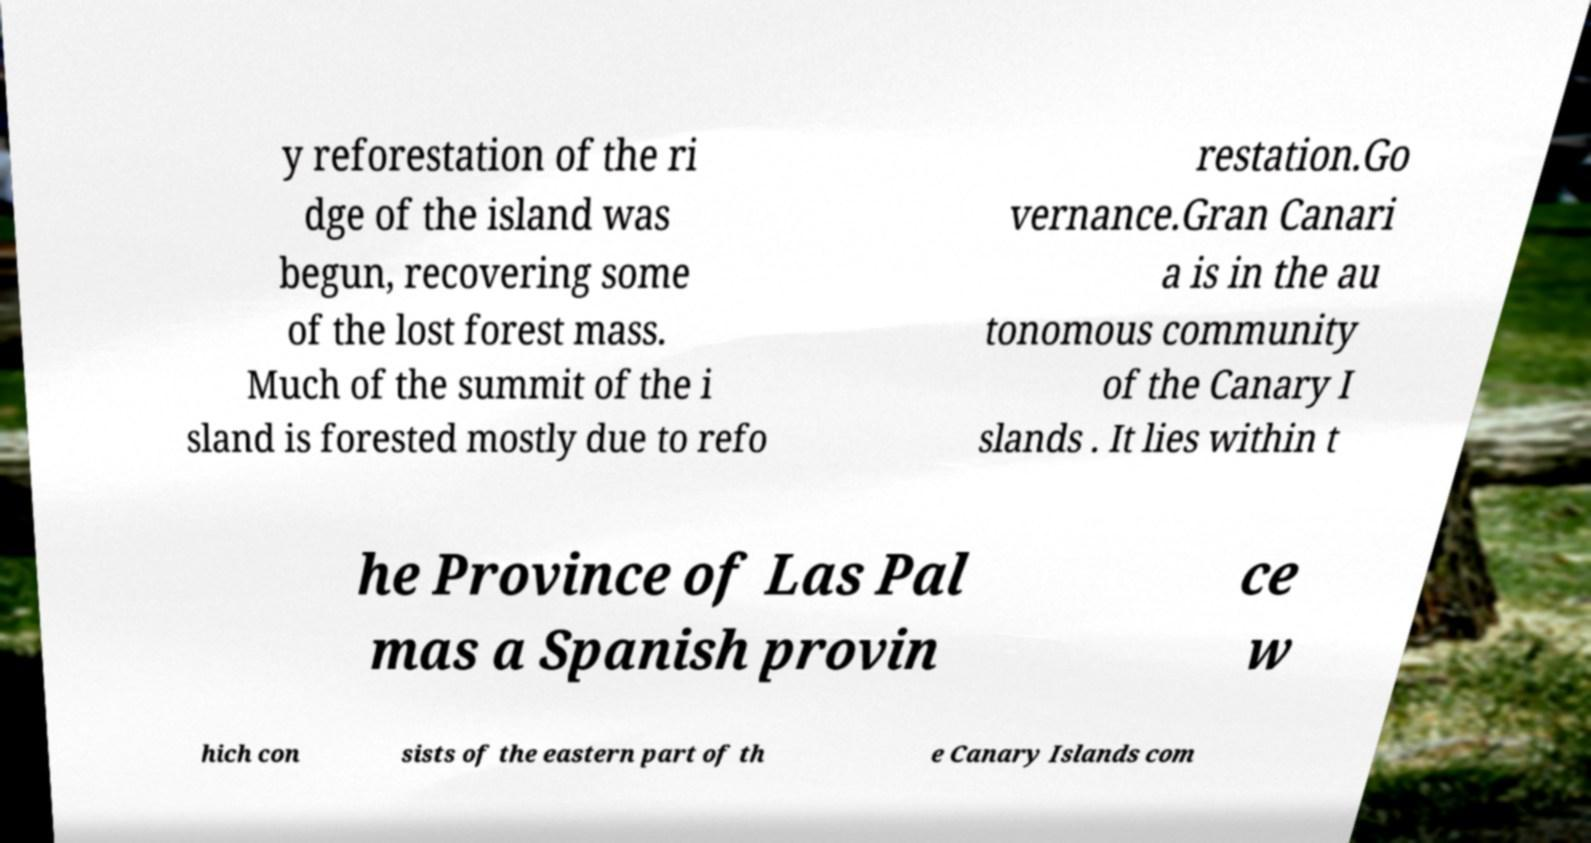Can you read and provide the text displayed in the image?This photo seems to have some interesting text. Can you extract and type it out for me? y reforestation of the ri dge of the island was begun, recovering some of the lost forest mass. Much of the summit of the i sland is forested mostly due to refo restation.Go vernance.Gran Canari a is in the au tonomous community of the Canary I slands . It lies within t he Province of Las Pal mas a Spanish provin ce w hich con sists of the eastern part of th e Canary Islands com 